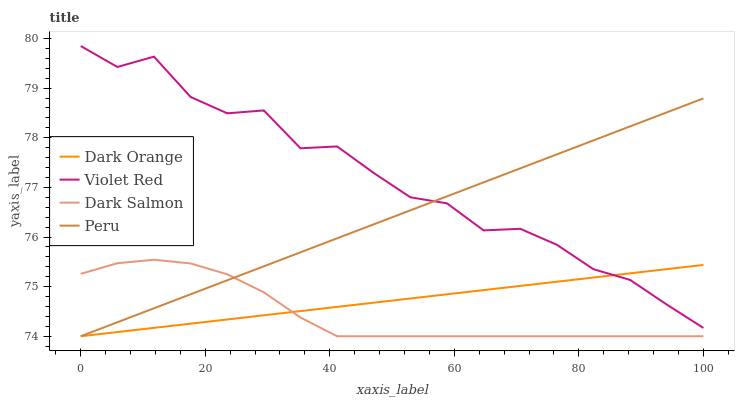Does Dark Salmon have the minimum area under the curve?
Answer yes or no. Yes. Does Violet Red have the maximum area under the curve?
Answer yes or no. Yes. Does Violet Red have the minimum area under the curve?
Answer yes or no. No. Does Dark Salmon have the maximum area under the curve?
Answer yes or no. No. Is Dark Orange the smoothest?
Answer yes or no. Yes. Is Violet Red the roughest?
Answer yes or no. Yes. Is Dark Salmon the smoothest?
Answer yes or no. No. Is Dark Salmon the roughest?
Answer yes or no. No. Does Dark Orange have the lowest value?
Answer yes or no. Yes. Does Violet Red have the lowest value?
Answer yes or no. No. Does Violet Red have the highest value?
Answer yes or no. Yes. Does Dark Salmon have the highest value?
Answer yes or no. No. Is Dark Salmon less than Violet Red?
Answer yes or no. Yes. Is Violet Red greater than Dark Salmon?
Answer yes or no. Yes. Does Dark Orange intersect Peru?
Answer yes or no. Yes. Is Dark Orange less than Peru?
Answer yes or no. No. Is Dark Orange greater than Peru?
Answer yes or no. No. Does Dark Salmon intersect Violet Red?
Answer yes or no. No. 